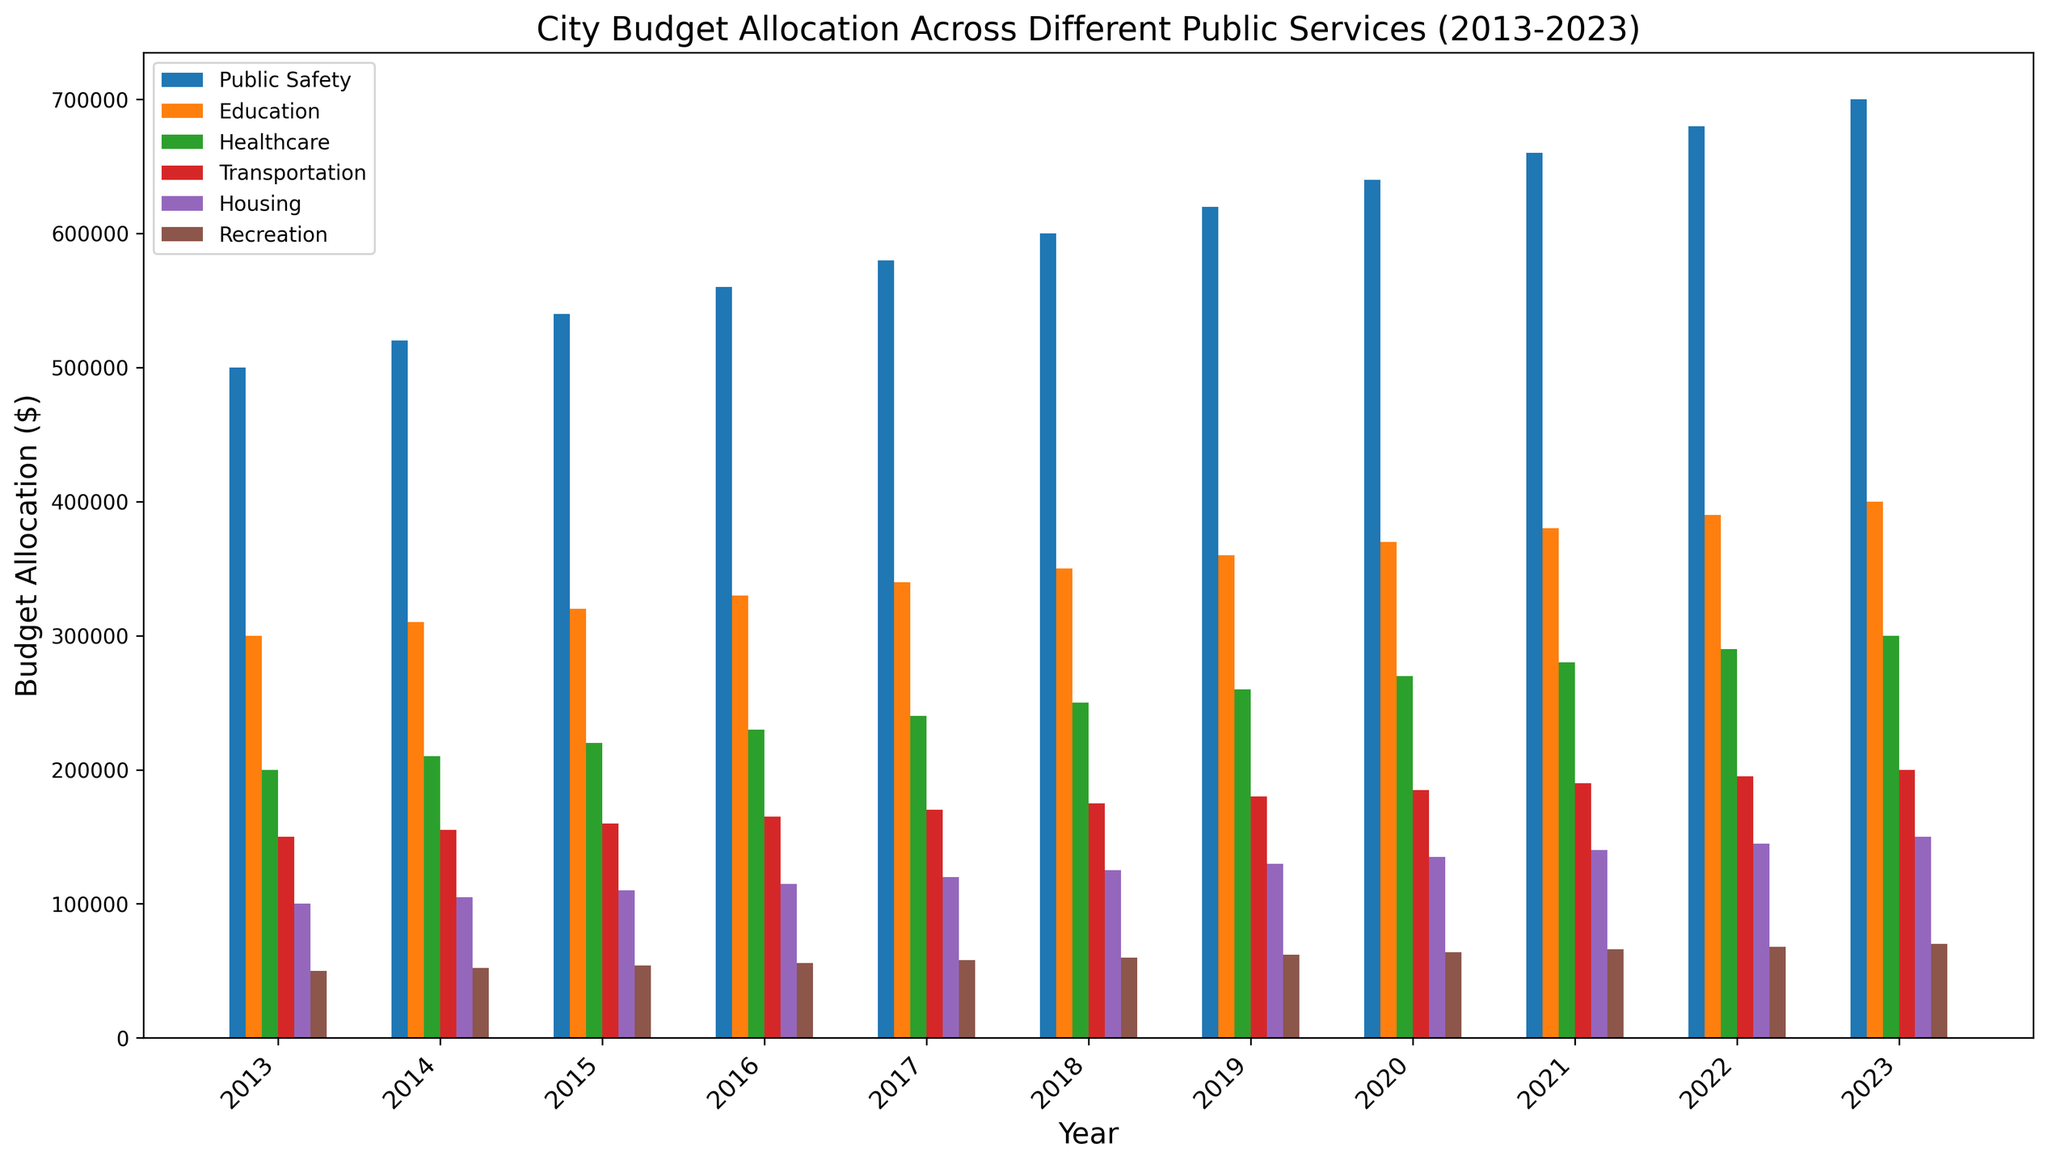What is the total budget for Public Safety over the decade? Sum the values of Public Safety from 2013 to 2023: 500000 + 520000 + 540000 + 560000 + 580000 + 600000 + 620000 + 640000 + 660000 + 680000 + 700000 = 6400000
Answer: 6400000 Which public service had the highest budget allocation in 2023? Look at the bar heights for 2023 and identify which bar is the tallest. Public Safety has the tallest bar in 2023.
Answer: Public Safety What is the average budget allocated to Housing from 2013 to 2023? Sum the Housing values and divide by the number of years: (100000 + 105000 + 110000 + 115000 + 120000 + 125000 + 130000 + 135000 + 140000 + 145000 + 150000) / 11 = 126363.63
Answer: 126363.63 Has the budget allocation for Recreation increased or decreased over the decade? Compare the bar heights for Recreation from 2013 to 2023. Each year shows an increase in bar height for Recreation.
Answer: Increased Which year had the lowest total budget allocation across all public services? Sum the budget allocations for each year and compare. 2013 has the lowest sum: 500000 + 300000 + 200000 + 150000 + 100000 + 50000 = 1300000
Answer: 2013 How does the budget allocation for Transportation in 2020 compare to Healthcare in 2020? Compare the bar heights for Transportation and Healthcare in 2020. Transportation is $185,000, and Healthcare is $270,000; Healthcare is higher.
Answer: Healthcare is higher What is the rate of increase in the Education budget from 2013 to 2023? Calculate the increase and divide by the number of years: (400000 - 300000) / 10 = 10000 per year
Answer: 10,000 per year How many times has the budget for Public Safety been exactly $600,000? Check the bars for Public Safety and see in which year it is exactly $600,000. Only in 2018
Answer: 1 Are there any public services where the budget has exactly tripled from 2013 to 2023? Compare the 2023 values to three times the 2013 values for each category. (Public Safety: 700000 vs. 1500000, Education: 400000 vs. 900000, Healthcare: 300000 vs. 600000, Transportation: 200000 vs. 450000, Housing: 150000 vs. 300000, Recreation: 70000 vs. 150000) None match
Answer: No Which public service had the most consistent annual budget increases? Visually examine the bars for consistent equal increments each year. Public Safety shows consistent yearly increases.
Answer: Public Safety 